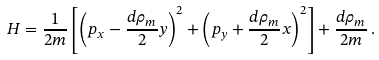<formula> <loc_0><loc_0><loc_500><loc_500>H = \frac { 1 } { 2 m } \left [ \left ( p _ { x } - \frac { d \rho _ { m } } { 2 } y \right ) ^ { 2 } + \left ( p _ { y } + \frac { d \rho _ { m } } { 2 } x \right ) ^ { 2 } \right ] + \frac { d \rho _ { m } } { 2 m } \, .</formula> 